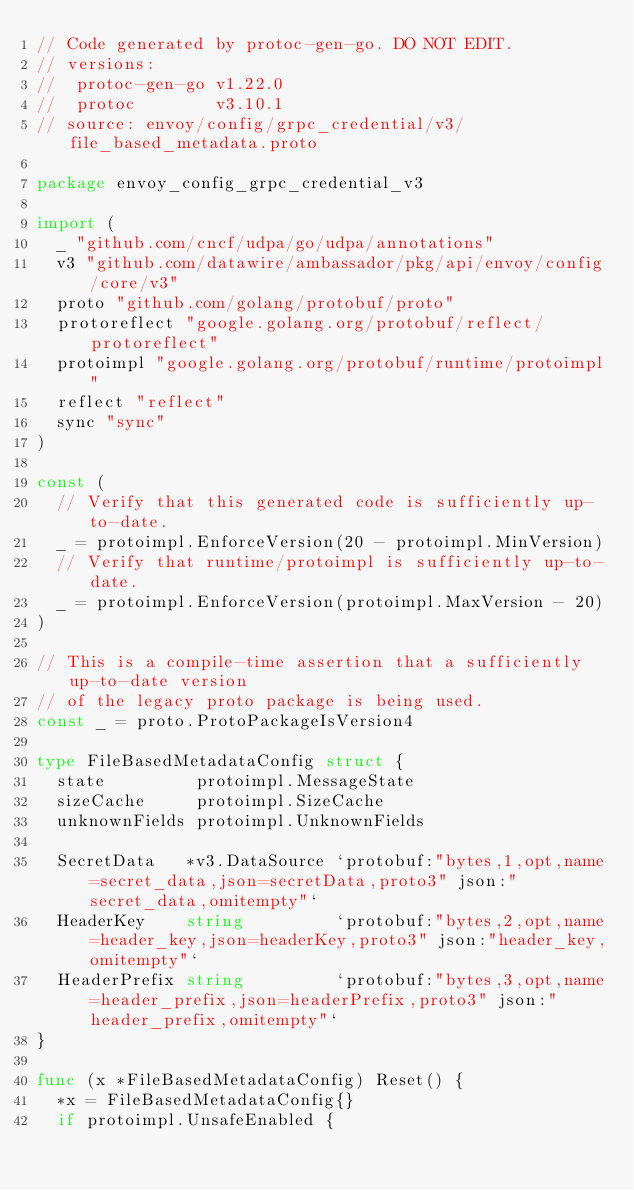Convert code to text. <code><loc_0><loc_0><loc_500><loc_500><_Go_>// Code generated by protoc-gen-go. DO NOT EDIT.
// versions:
// 	protoc-gen-go v1.22.0
// 	protoc        v3.10.1
// source: envoy/config/grpc_credential/v3/file_based_metadata.proto

package envoy_config_grpc_credential_v3

import (
	_ "github.com/cncf/udpa/go/udpa/annotations"
	v3 "github.com/datawire/ambassador/pkg/api/envoy/config/core/v3"
	proto "github.com/golang/protobuf/proto"
	protoreflect "google.golang.org/protobuf/reflect/protoreflect"
	protoimpl "google.golang.org/protobuf/runtime/protoimpl"
	reflect "reflect"
	sync "sync"
)

const (
	// Verify that this generated code is sufficiently up-to-date.
	_ = protoimpl.EnforceVersion(20 - protoimpl.MinVersion)
	// Verify that runtime/protoimpl is sufficiently up-to-date.
	_ = protoimpl.EnforceVersion(protoimpl.MaxVersion - 20)
)

// This is a compile-time assertion that a sufficiently up-to-date version
// of the legacy proto package is being used.
const _ = proto.ProtoPackageIsVersion4

type FileBasedMetadataConfig struct {
	state         protoimpl.MessageState
	sizeCache     protoimpl.SizeCache
	unknownFields protoimpl.UnknownFields

	SecretData   *v3.DataSource `protobuf:"bytes,1,opt,name=secret_data,json=secretData,proto3" json:"secret_data,omitempty"`
	HeaderKey    string         `protobuf:"bytes,2,opt,name=header_key,json=headerKey,proto3" json:"header_key,omitempty"`
	HeaderPrefix string         `protobuf:"bytes,3,opt,name=header_prefix,json=headerPrefix,proto3" json:"header_prefix,omitempty"`
}

func (x *FileBasedMetadataConfig) Reset() {
	*x = FileBasedMetadataConfig{}
	if protoimpl.UnsafeEnabled {</code> 